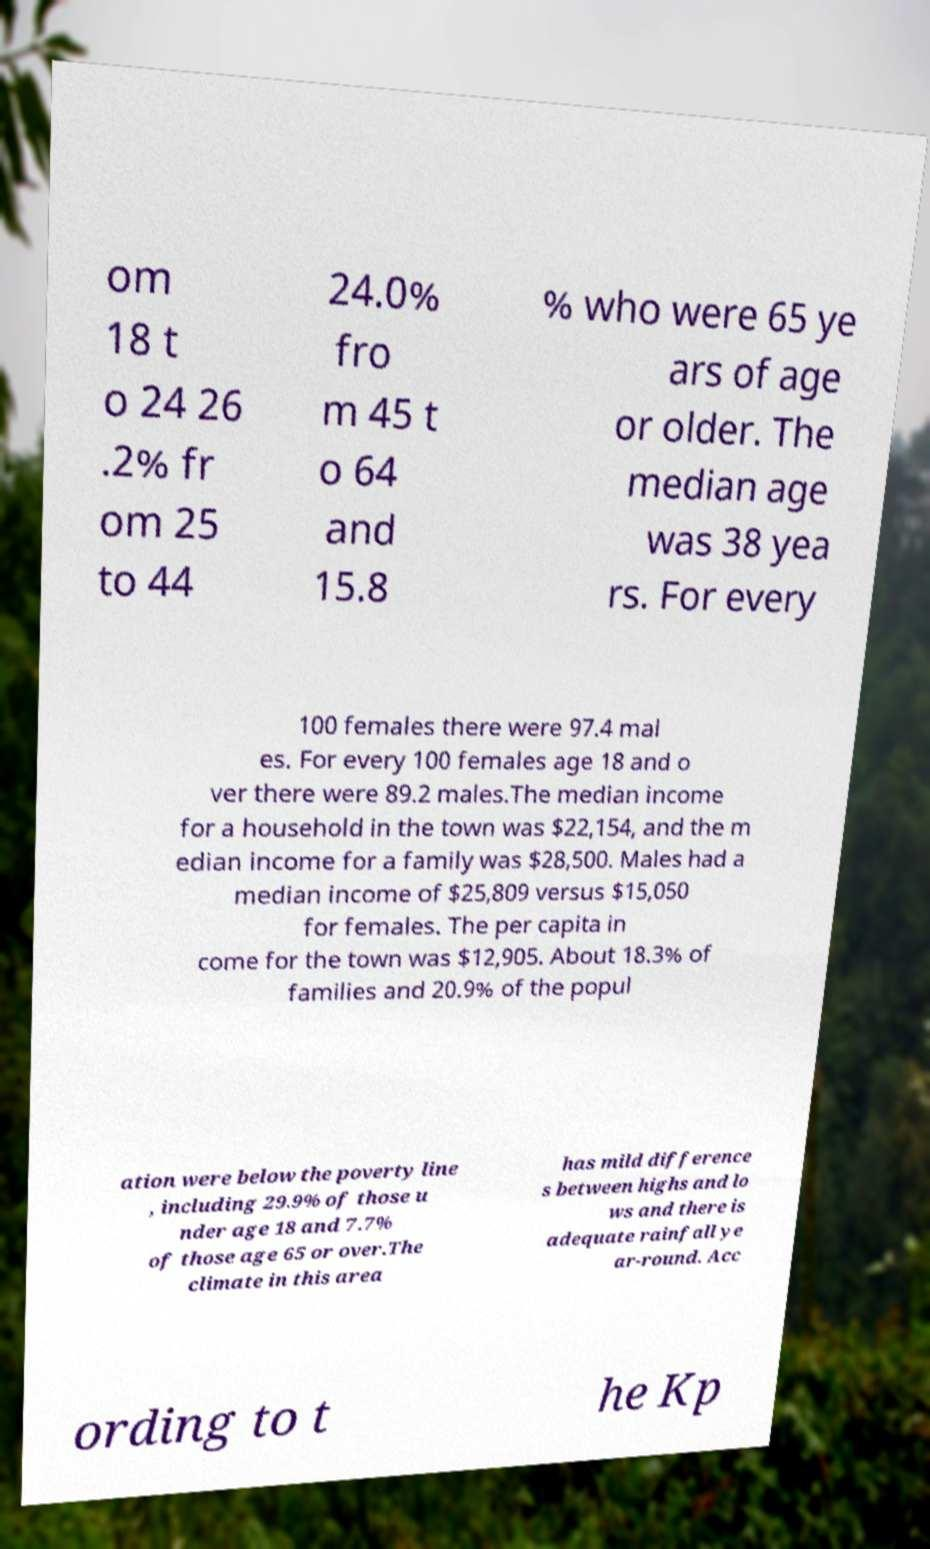Please read and relay the text visible in this image. What does it say? om 18 t o 24 26 .2% fr om 25 to 44 24.0% fro m 45 t o 64 and 15.8 % who were 65 ye ars of age or older. The median age was 38 yea rs. For every 100 females there were 97.4 mal es. For every 100 females age 18 and o ver there were 89.2 males.The median income for a household in the town was $22,154, and the m edian income for a family was $28,500. Males had a median income of $25,809 versus $15,050 for females. The per capita in come for the town was $12,905. About 18.3% of families and 20.9% of the popul ation were below the poverty line , including 29.9% of those u nder age 18 and 7.7% of those age 65 or over.The climate in this area has mild difference s between highs and lo ws and there is adequate rainfall ye ar-round. Acc ording to t he Kp 